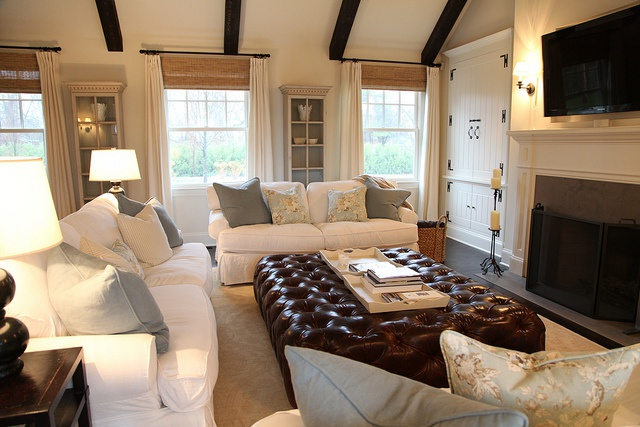Describe the objects in this image and their specific colors. I can see couch in gray, tan, beige, and darkgray tones, couch in gray and tan tones, tv in gray, black, maroon, and tan tones, book in gray, white, darkgray, and tan tones, and book in gray and tan tones in this image. 